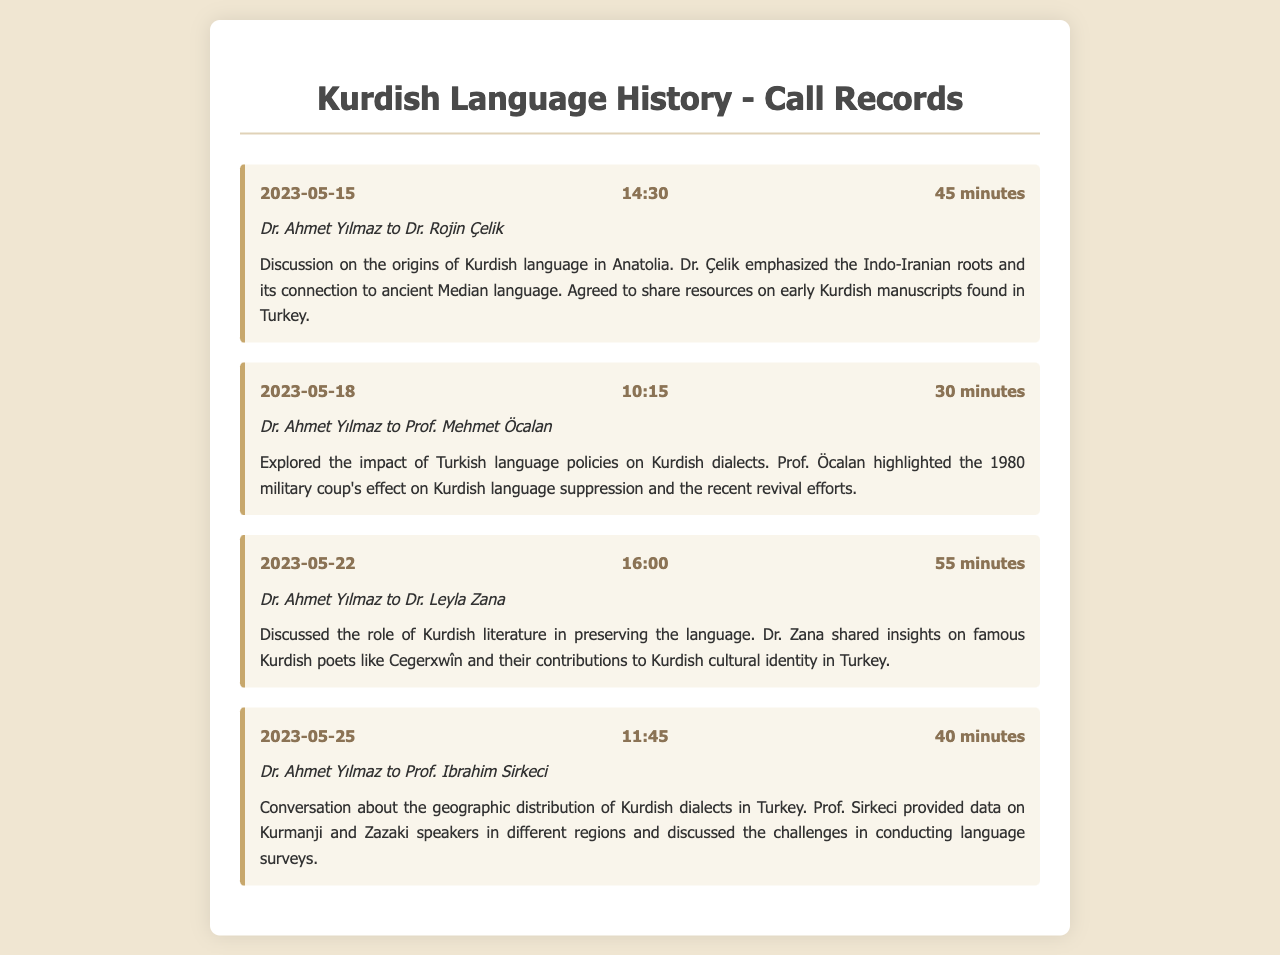What is the date of the conversation with Dr. Rojin Çelik? The date of the conversation with Dr. Rojin Çelik is listed in the call record.
Answer: 2023-05-15 Who discussed the impact of Turkish language policies? This is noted in one of the call records where Prof. Öcalan is mentioned.
Answer: Prof. Mehmet Öcalan How long was the call with Dr. Leyla Zana? The duration of the call with Dr. Leyla Zana is specified in the document.
Answer: 55 minutes What was emphasized in the conversation about the origins of the Kurdish language? The summary mentions a key point made by Dr. Çelik about language roots.
Answer: Indo-Iranian roots What literary figure was mentioned in the context of Kurdish literature? The call record highlights contributions to Kurdish cultural identity by a specific poet.
Answer: Cegerxwîn How many minutes did the call about Kurdish dialects last? The duration of the call with Prof. Ibrahim Sirkeci is included in the records.
Answer: 40 minutes What connection to ancient languages was highlighted in the discussions? This is explained in the call with Dr. Rojin Çelik, regarding language ancestry.
Answer: Median language What is the focus of the conversation on May 18? The topic of the call with Prof. Öcalan is referred to specifically in the summary.
Answer: Kurdish language suppression 